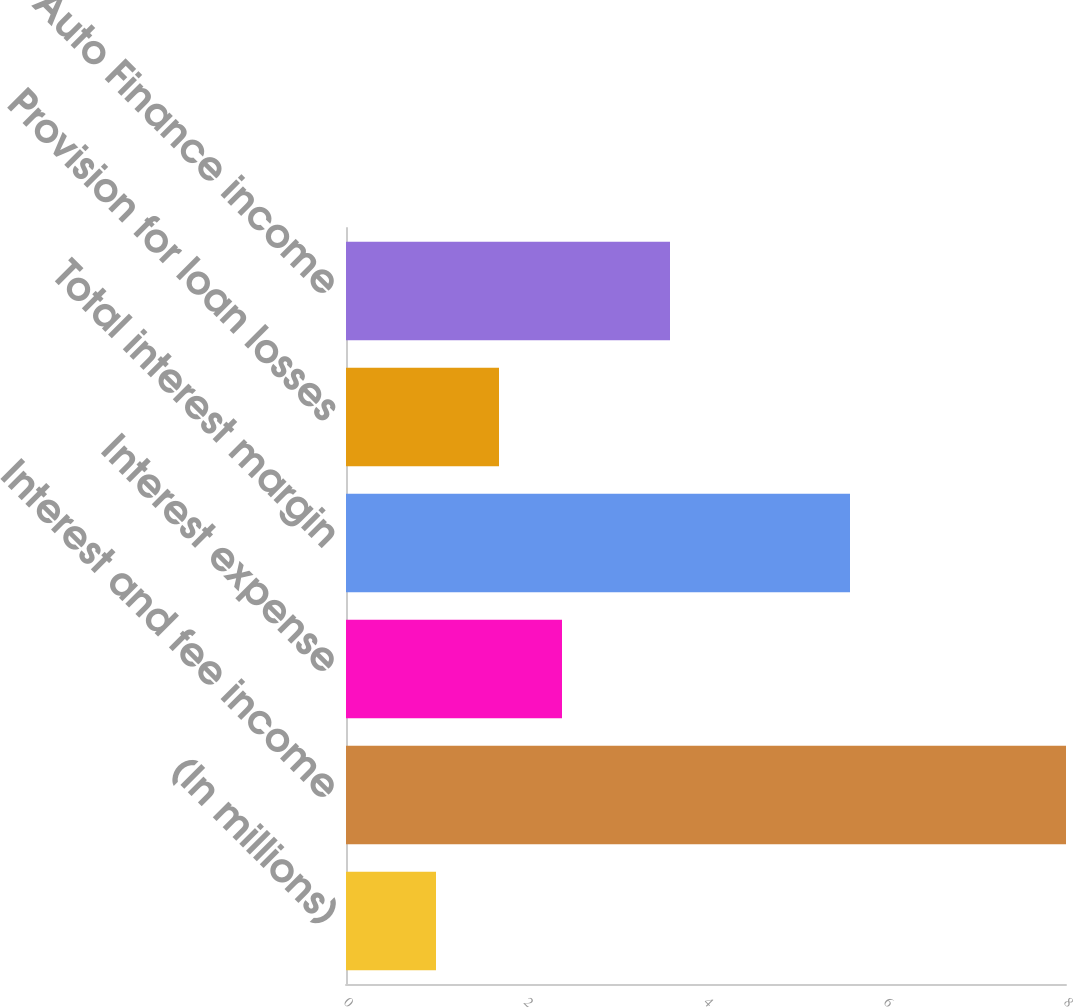Convert chart. <chart><loc_0><loc_0><loc_500><loc_500><bar_chart><fcel>(In millions)<fcel>Interest and fee income<fcel>Interest expense<fcel>Total interest margin<fcel>Provision for loan losses<fcel>CarMax Auto Finance income<nl><fcel>1<fcel>8<fcel>2.4<fcel>5.6<fcel>1.7<fcel>3.6<nl></chart> 